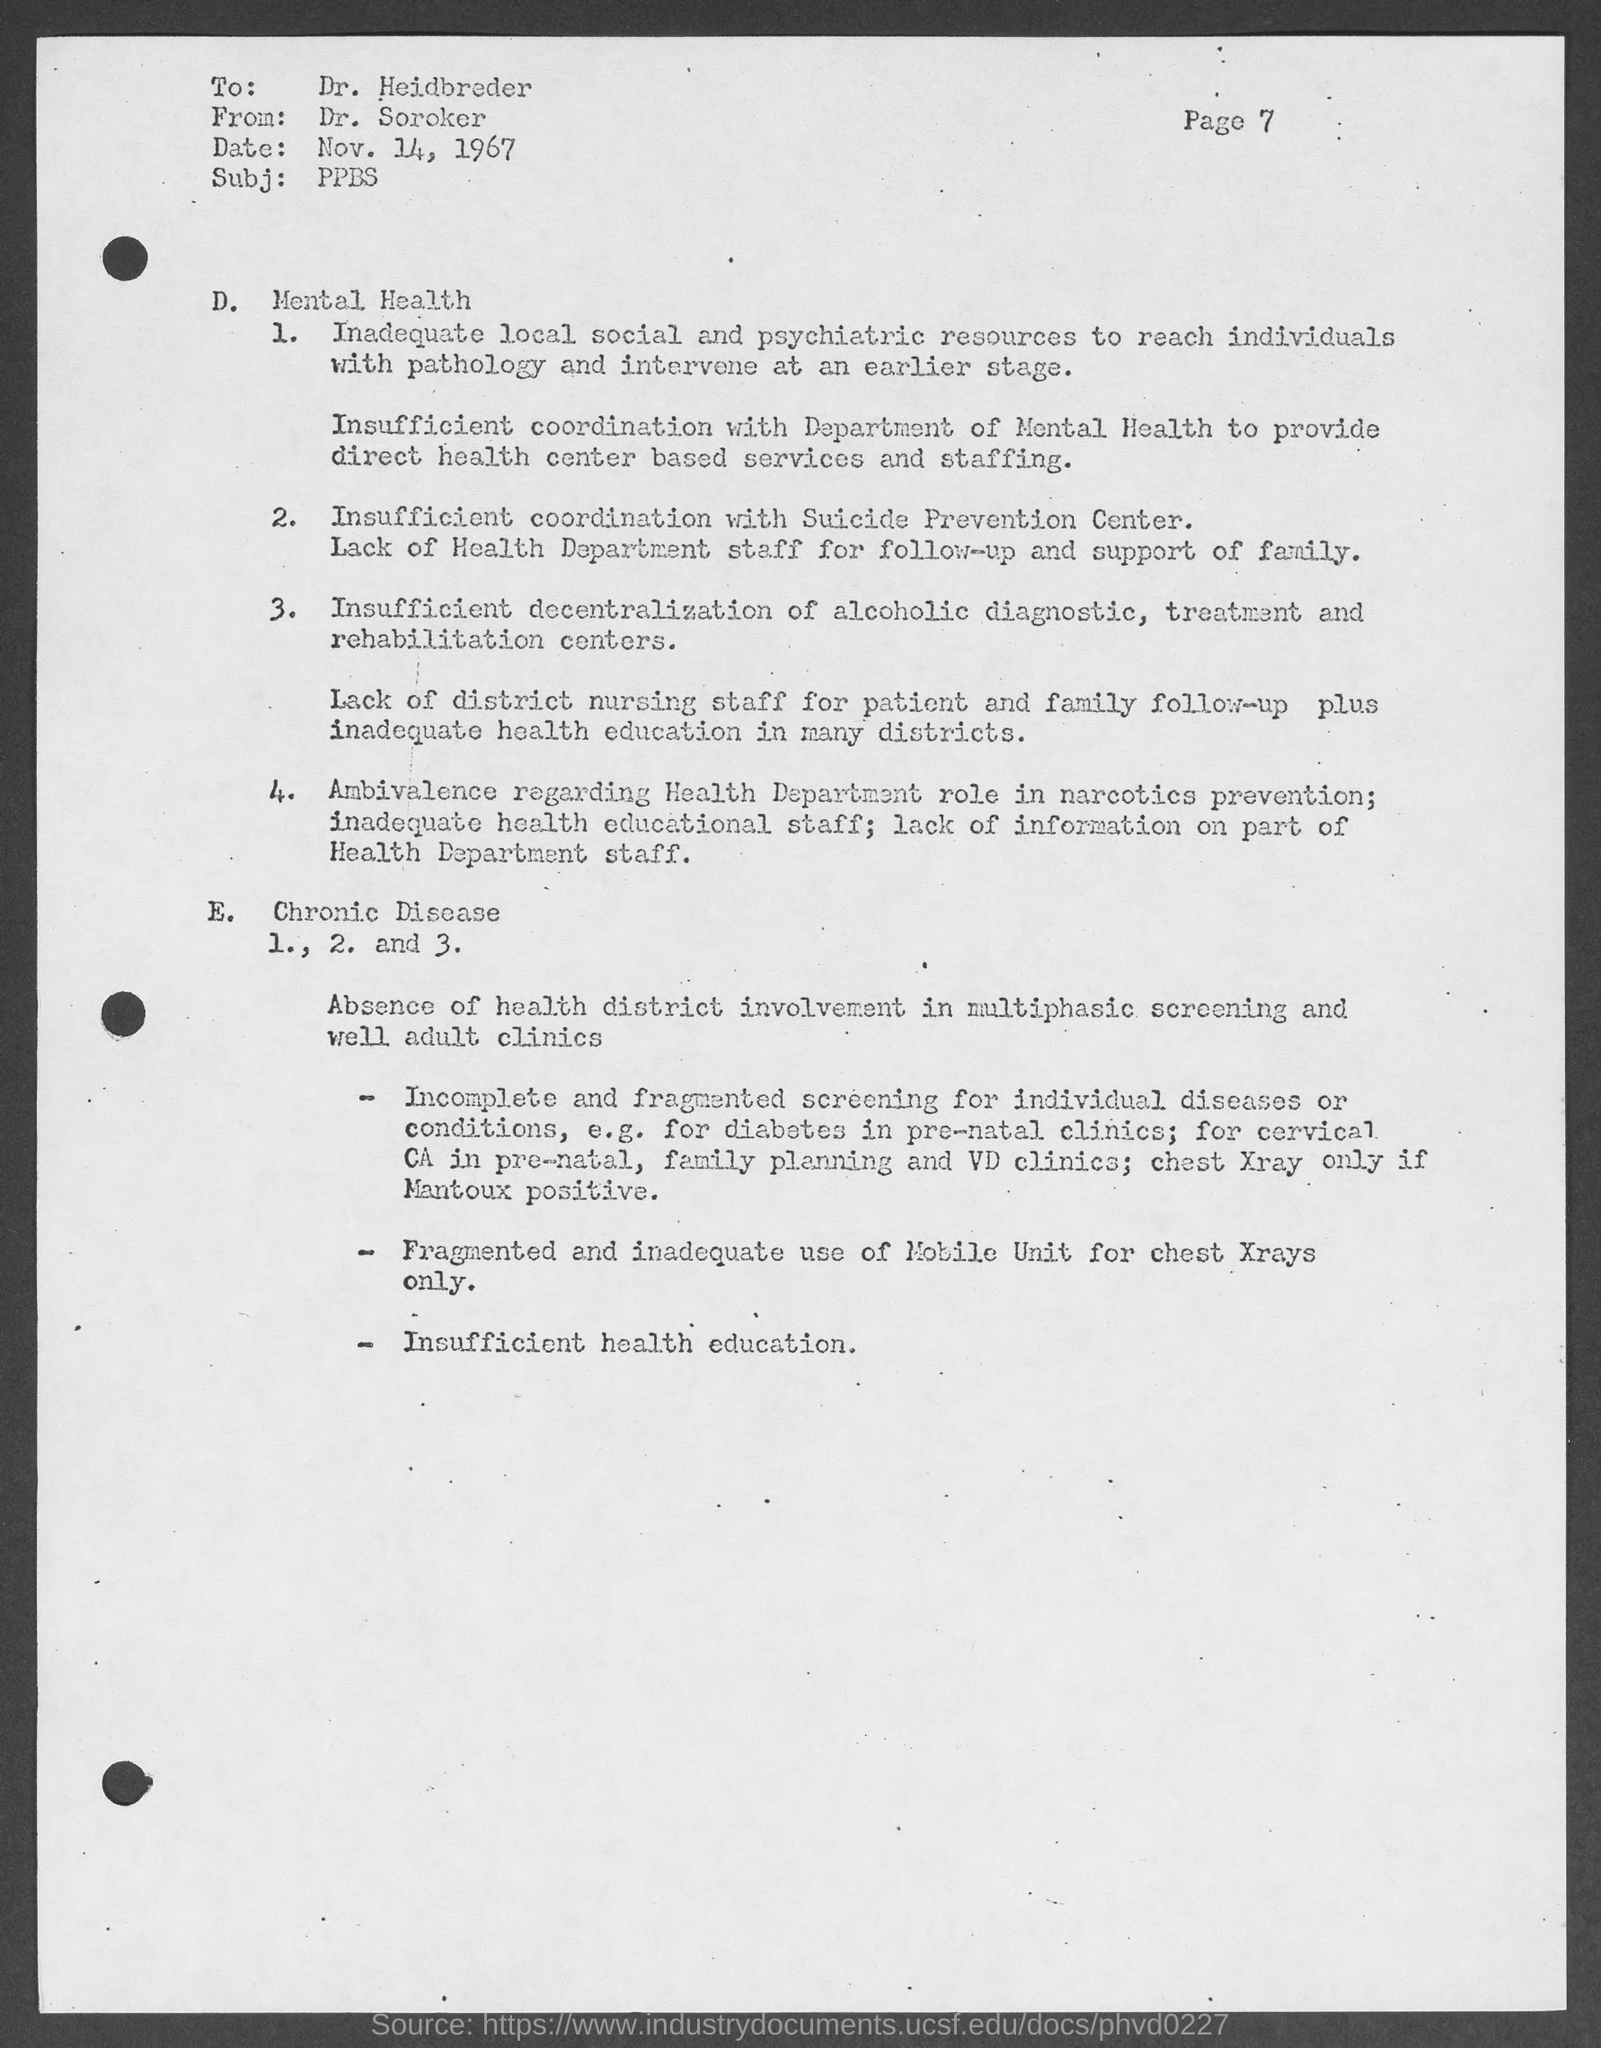List a handful of essential elements in this visual. The sender of this document is Dr. Soroker. The subject of this document is the PPBS. The recipient of this document is Dr. Heidbreder. The date mentioned in this document is November 14, 1967. 